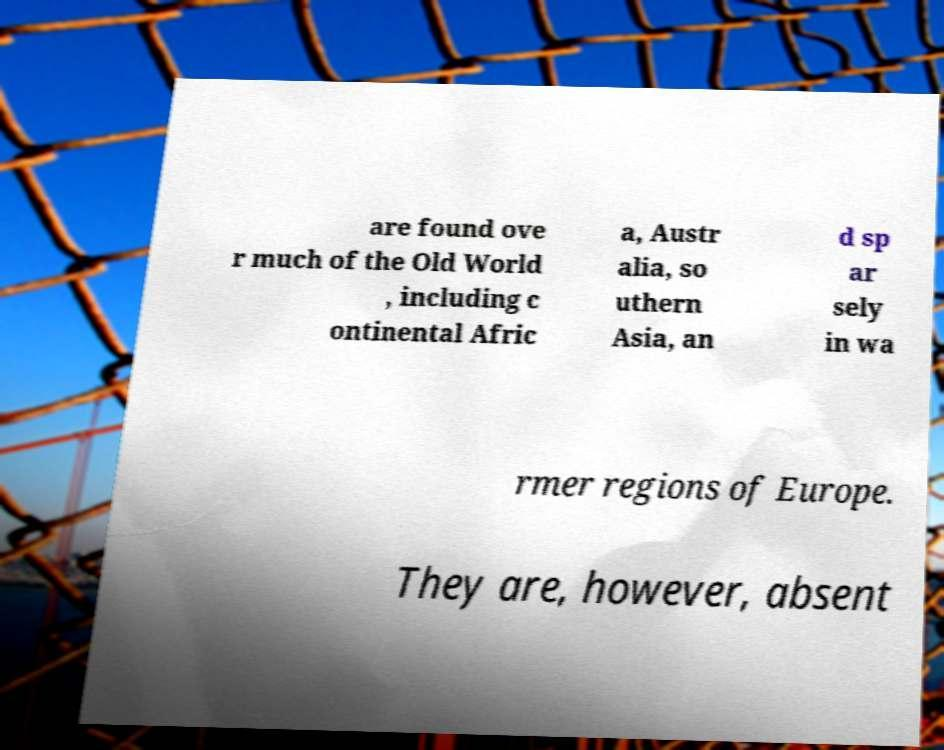I need the written content from this picture converted into text. Can you do that? are found ove r much of the Old World , including c ontinental Afric a, Austr alia, so uthern Asia, an d sp ar sely in wa rmer regions of Europe. They are, however, absent 